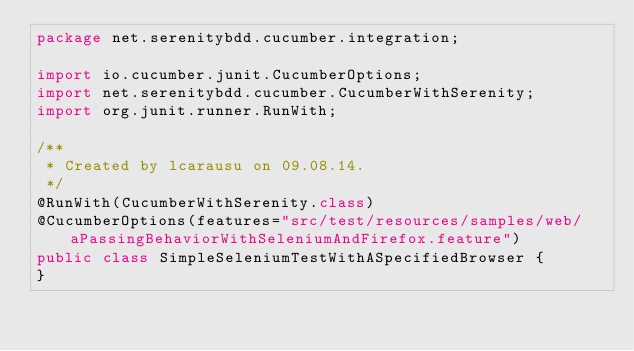Convert code to text. <code><loc_0><loc_0><loc_500><loc_500><_Java_>package net.serenitybdd.cucumber.integration;

import io.cucumber.junit.CucumberOptions;
import net.serenitybdd.cucumber.CucumberWithSerenity;
import org.junit.runner.RunWith;

/**
 * Created by lcarausu on 09.08.14.
 */
@RunWith(CucumberWithSerenity.class)
@CucumberOptions(features="src/test/resources/samples/web/aPassingBehaviorWithSeleniumAndFirefox.feature")
public class SimpleSeleniumTestWithASpecifiedBrowser {
}
</code> 